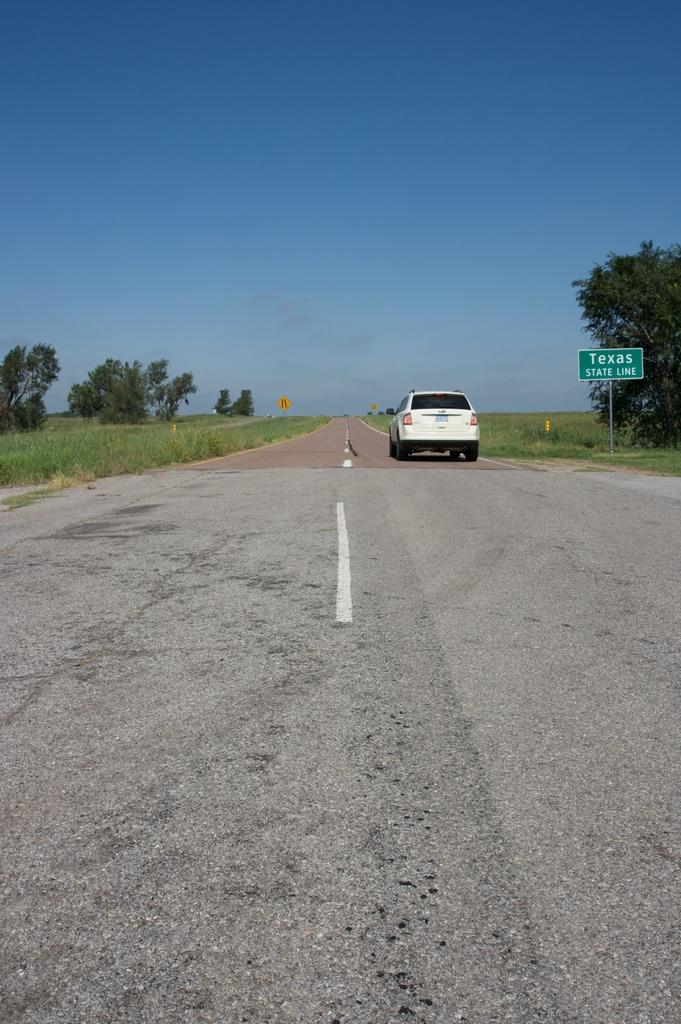What is the main subject of the image? There is a vehicle in the image. Can you describe the color of the vehicle? The vehicle is white in color. What else can be seen attached to a pole in the image? There is a green color board attached to a pole in the image. What type of natural environment is visible in the background of the image? Trees and grass are visible in the background of the image. What is the color of the sky in the image? The sky is blue in color. What type of stew is being served at the organization's event in the image? There is no organization, event, or stew present in the image. Can you tell me how many robins are perched on the vehicle in the image? There are no robins present in the image; the focus is on the vehicle and the green color board. 